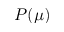Convert formula to latex. <formula><loc_0><loc_0><loc_500><loc_500>P ( \mu )</formula> 